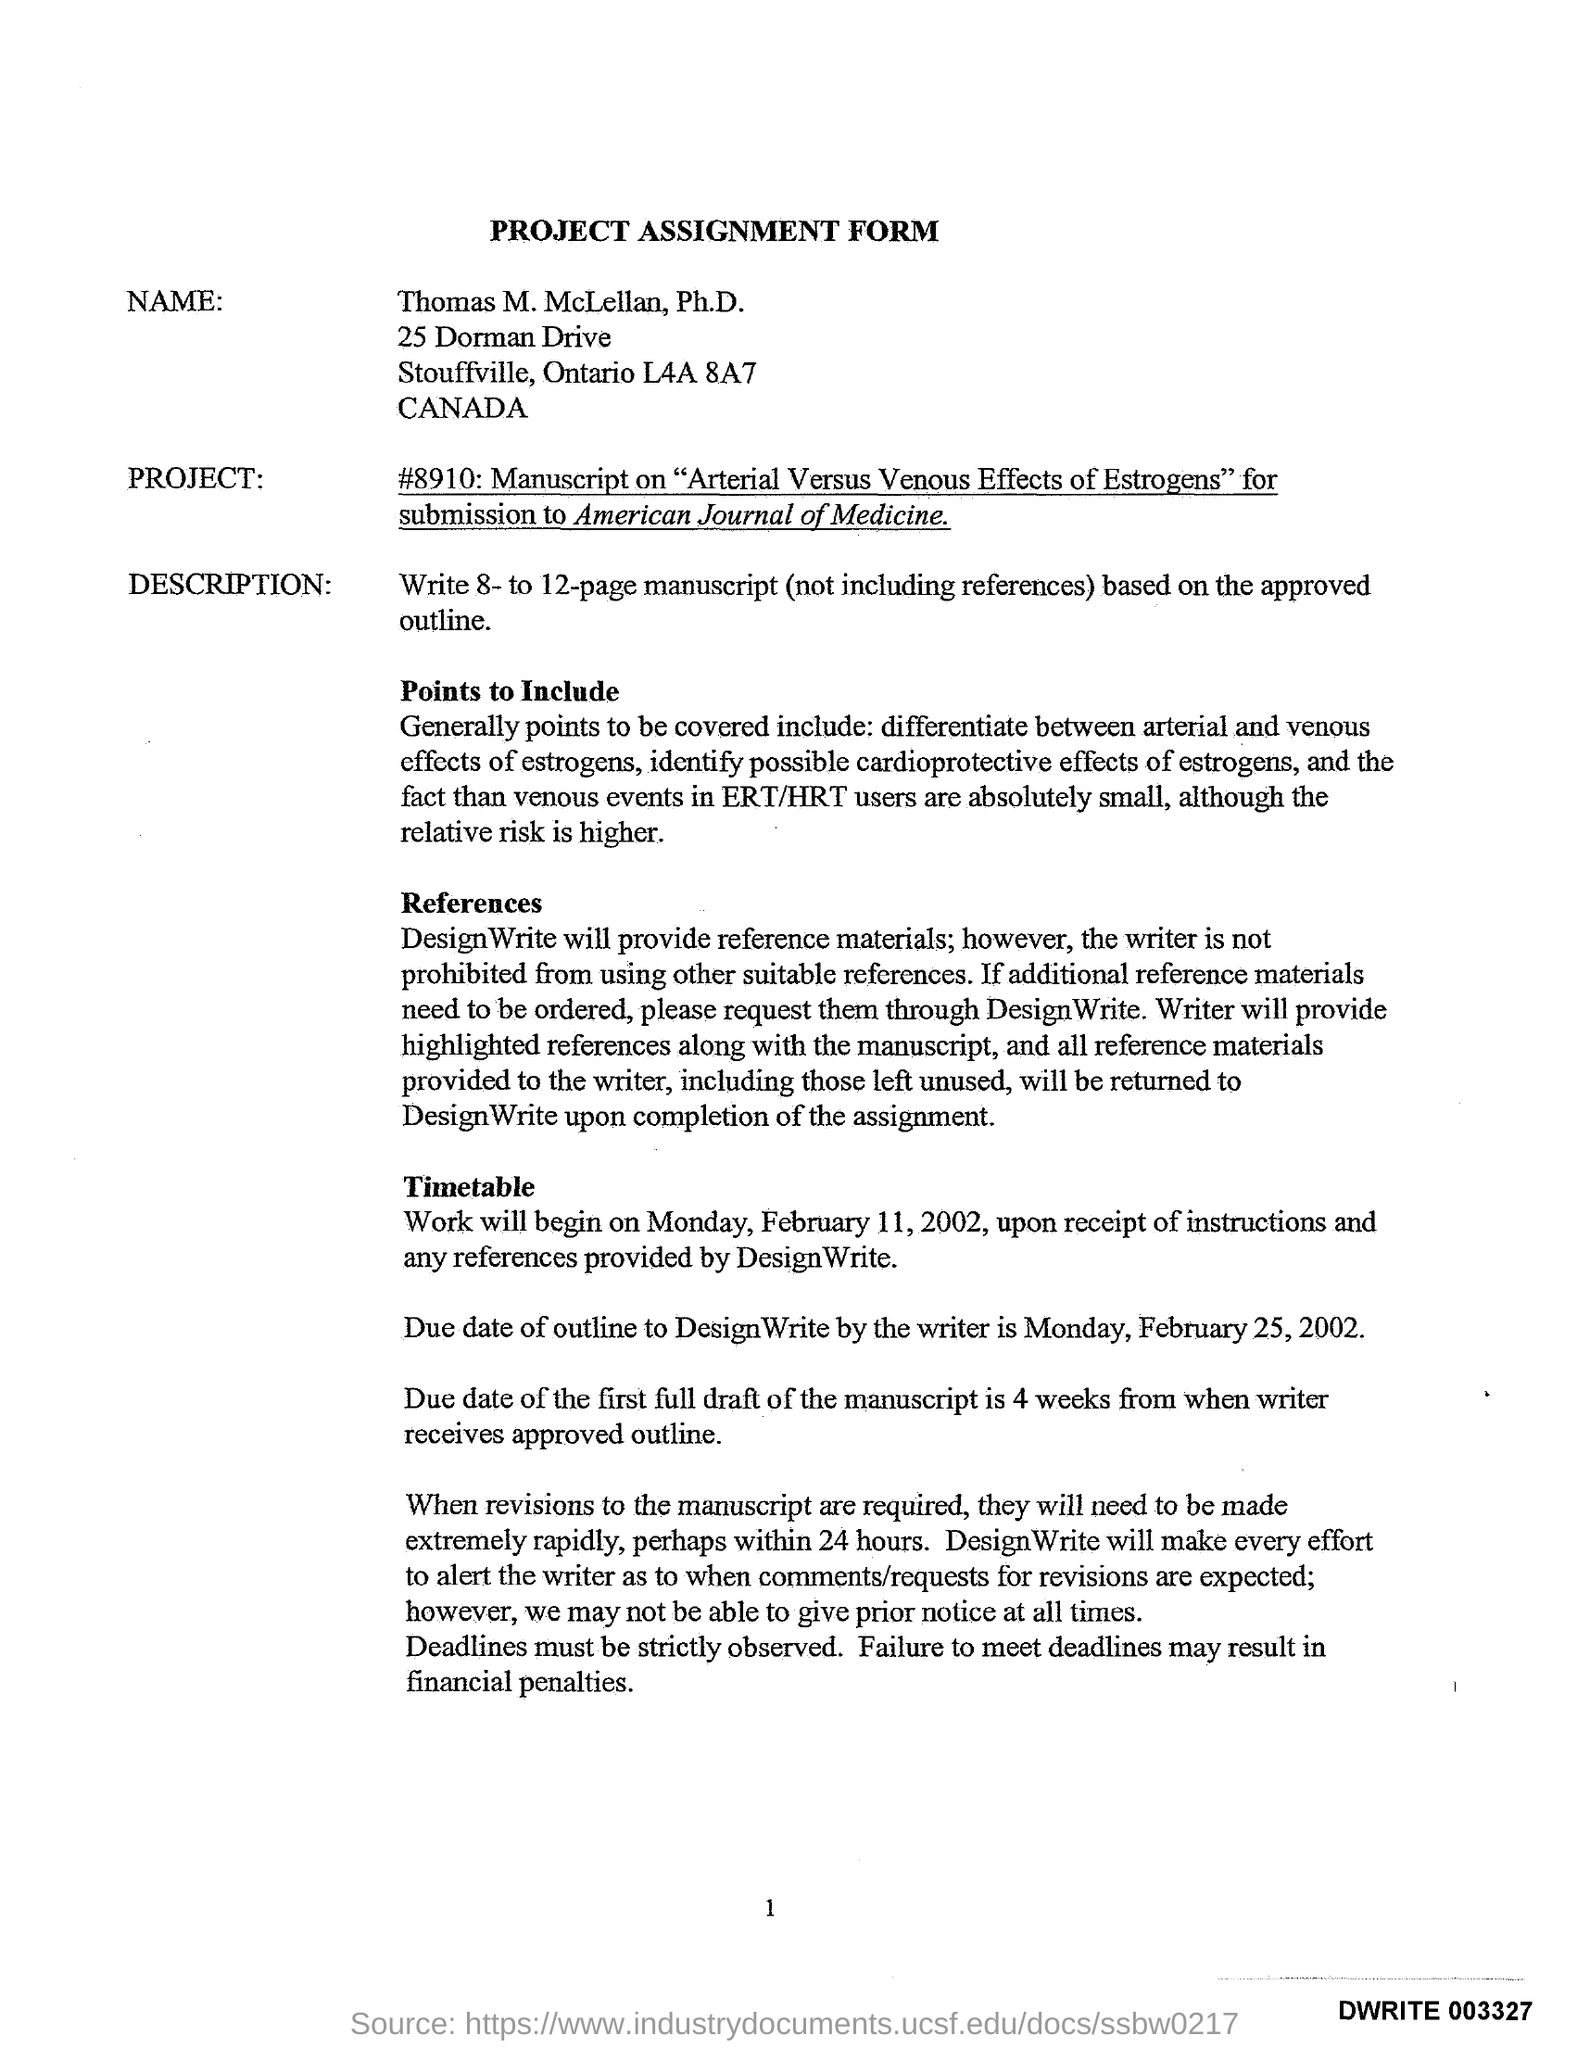Where is this project is submitted ?
Offer a very short reply. American Journal of Medicine. When was the project started?
Your answer should be compact. February 11, 2002. What is result, if failure to meet the deadlines ?
Give a very brief answer. Financial penalties. 